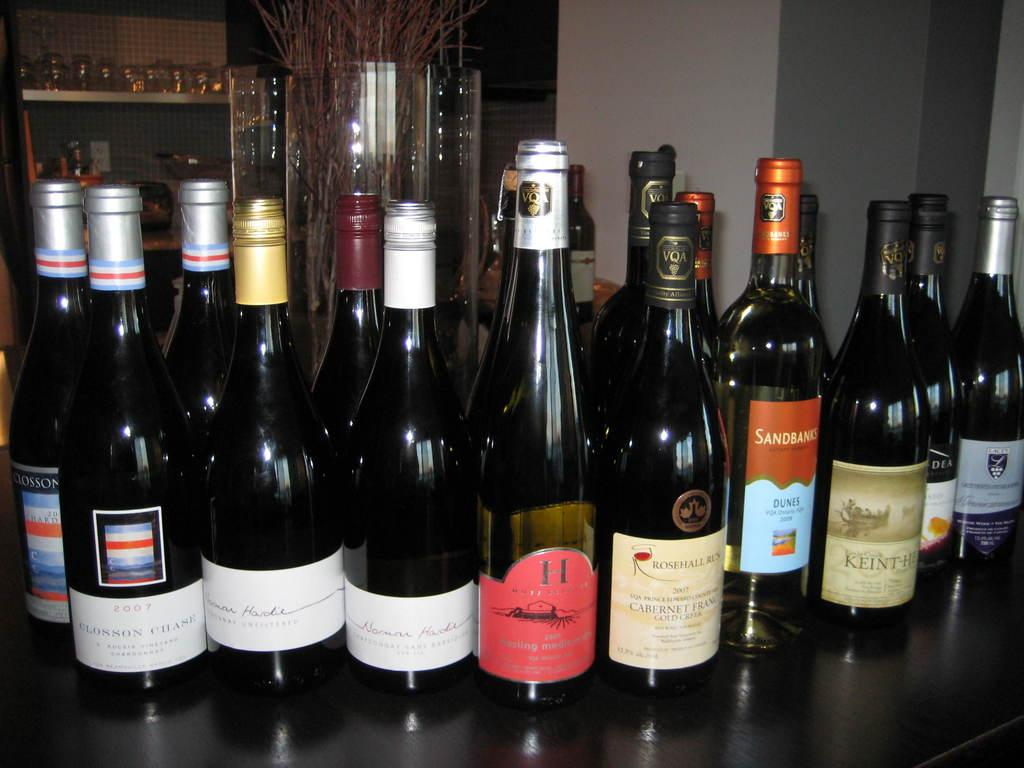<image>
Create a compact narrative representing the image presented. Bottles of alcohol on a table with one that says Sandbanks. 